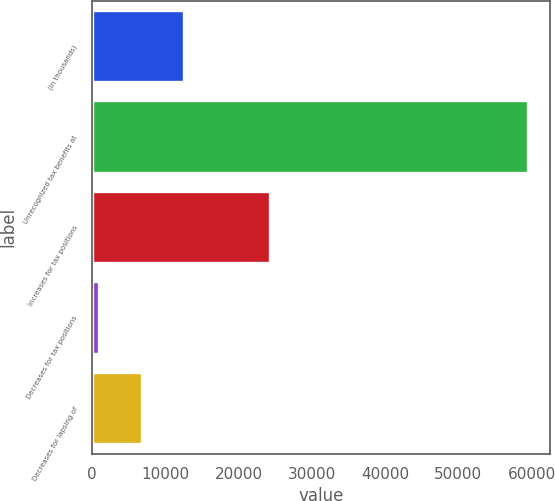Convert chart. <chart><loc_0><loc_0><loc_500><loc_500><bar_chart><fcel>(In thousands)<fcel>Unrecognized tax benefits at<fcel>Increases for tax positions<fcel>Decreases for tax positions<fcel>Decreases for lapsing of<nl><fcel>12622.8<fcel>59494<fcel>24340.6<fcel>905<fcel>6763.9<nl></chart> 